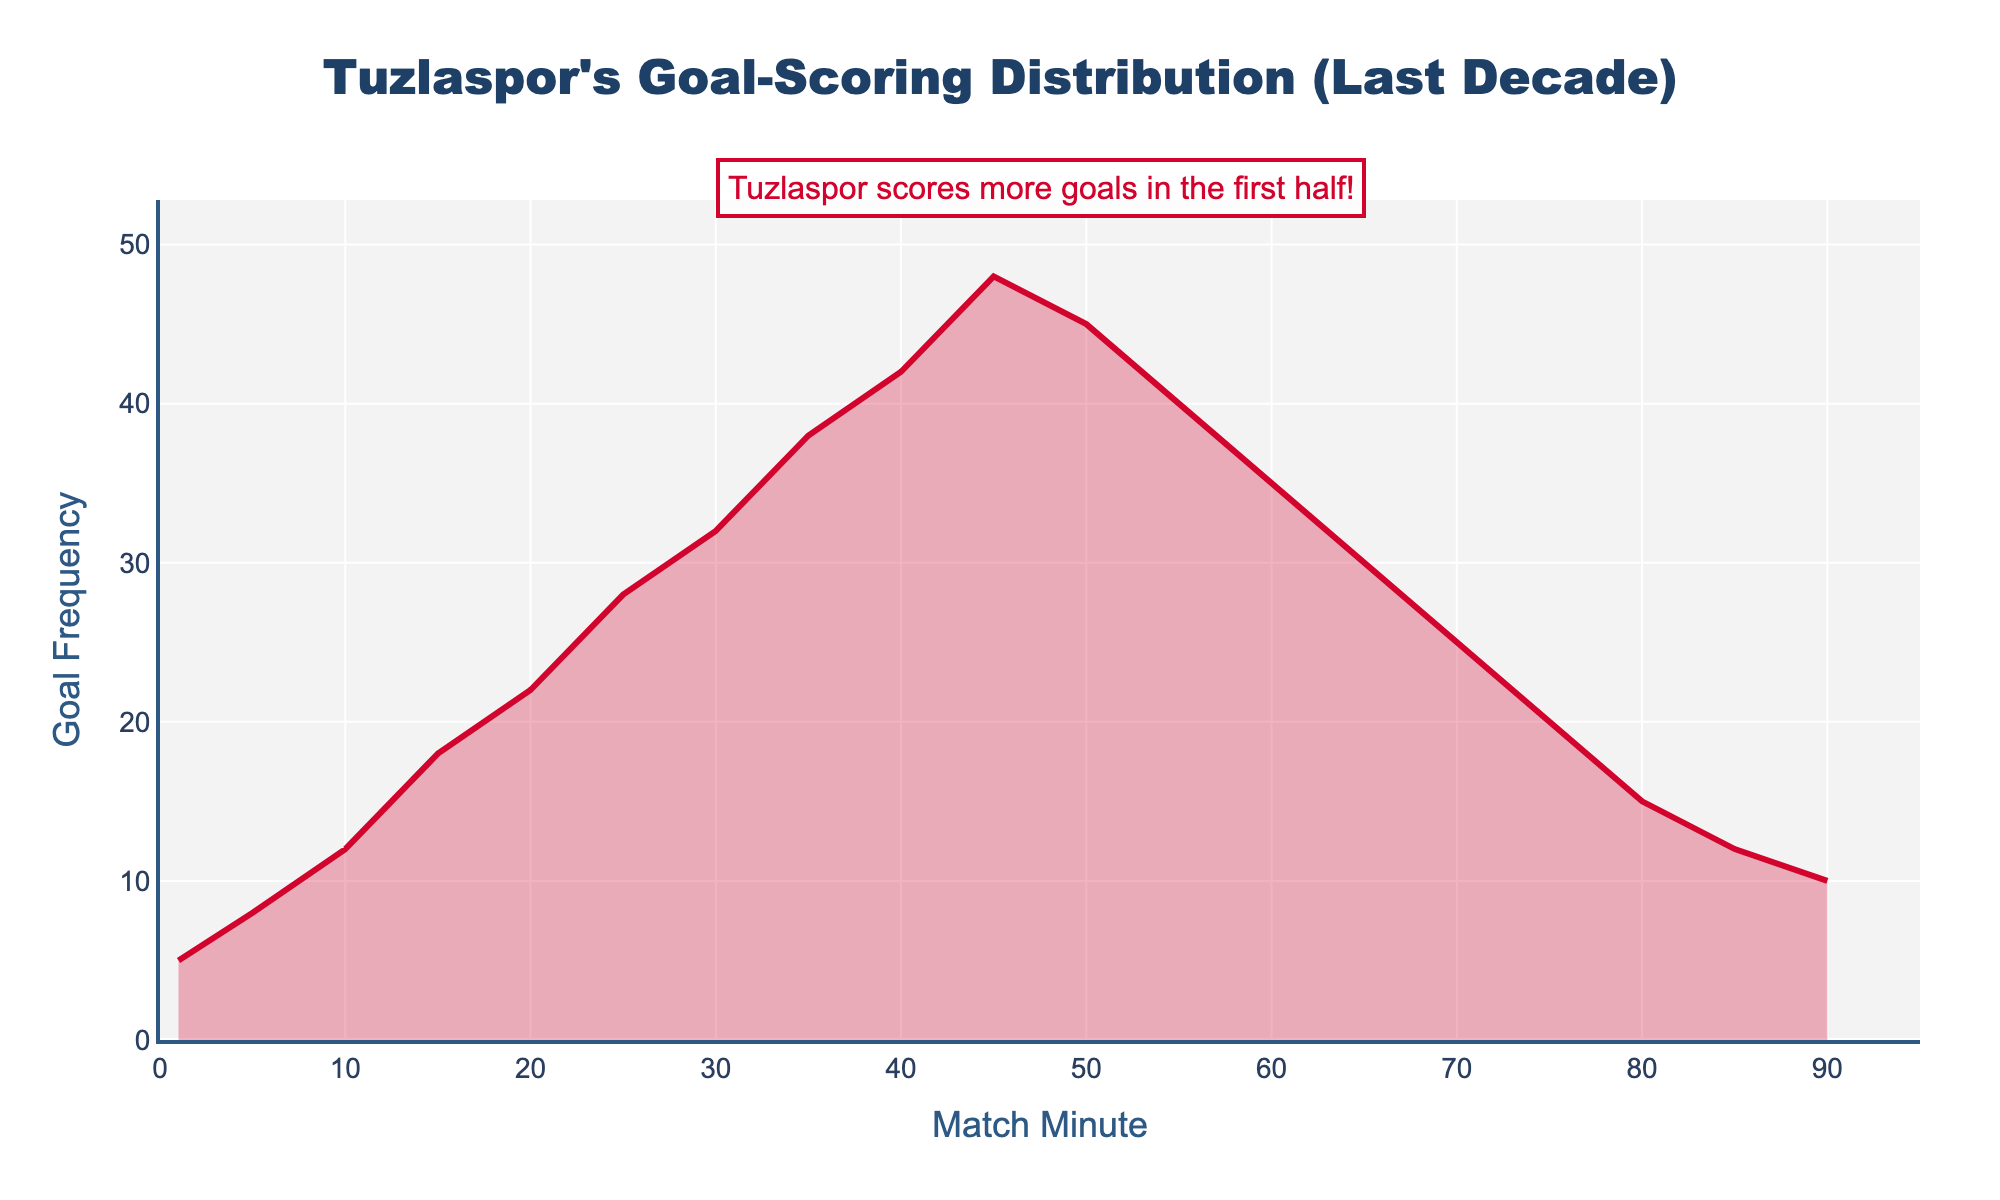What is the title of the plot? The title is usually found at the top of the plot and provides a brief description of the data being visualized. Here, the title should indicate Tuzlaspor's goal-scoring distribution over the past decade.
Answer: Tuzlaspor's Goal-Scoring Distribution (Last Decade) What does the y-axis represent? The y-axis typically represents the dependent variable in the data, which in this case is the frequency of goals scored by Tuzlaspor at different times in the match.
Answer: Goal Frequency What is the color used for the line in the plot? The plot uses a red line to represent the data, which can be described by referring to the color rather than any specific coding term.
Answer: Red At which match minute does Tuzlaspor score the most goals? To find this, look for the peak of the plot. The highest point on the y-axis corresponds to the match minute on the x-axis where the goal frequency is the highest.
Answer: 45th minute How many goals does Tuzlaspor score at the 40th minute compared to the 20th minute? Compare the frequencies at the 40th and 20th-minute marks by reading the corresponding values on the y-axis.
Answer: 42 at 40th minute, 22 at 20th minute What trend can be observed about Tuzlaspor's goal-scoring frequency as the match progresses? To deduce this, observe the general shape and direction of the plot from the start to the end.
Answer: Decreases after 45th minute What is the combined frequency of goals scored between the 10th and 30th minutes? Add the frequencies of goals scored at the 10th (12), 15th (18), 20th (22), 25th (28), and 30th (32) minutes. 12 + 18 + 22 + 28 + 32 = 112
Answer: 112 How does the goal frequency at the 60th minute compare to that at the 70th minute? Compare the values from the y-axis at these two specific points to determine whether one is higher, lower, or if they are the same.
Answer: Higher at 60th minute (35 vs 25) During which half of the match does Tuzlaspor score more goals, based on the given data? To understand this, compare the cumulative goal frequencies for the first half (1-45 mins) and the second half (46-90 mins). The higher cumulative total indicates where more goals are scored.
Answer: First half What is the range of the x-axis on the plot? Identify the minimum and maximum values displayed on the x-axis to understand the full span of match minutes visualized in the plot.
Answer: 0 to 95 